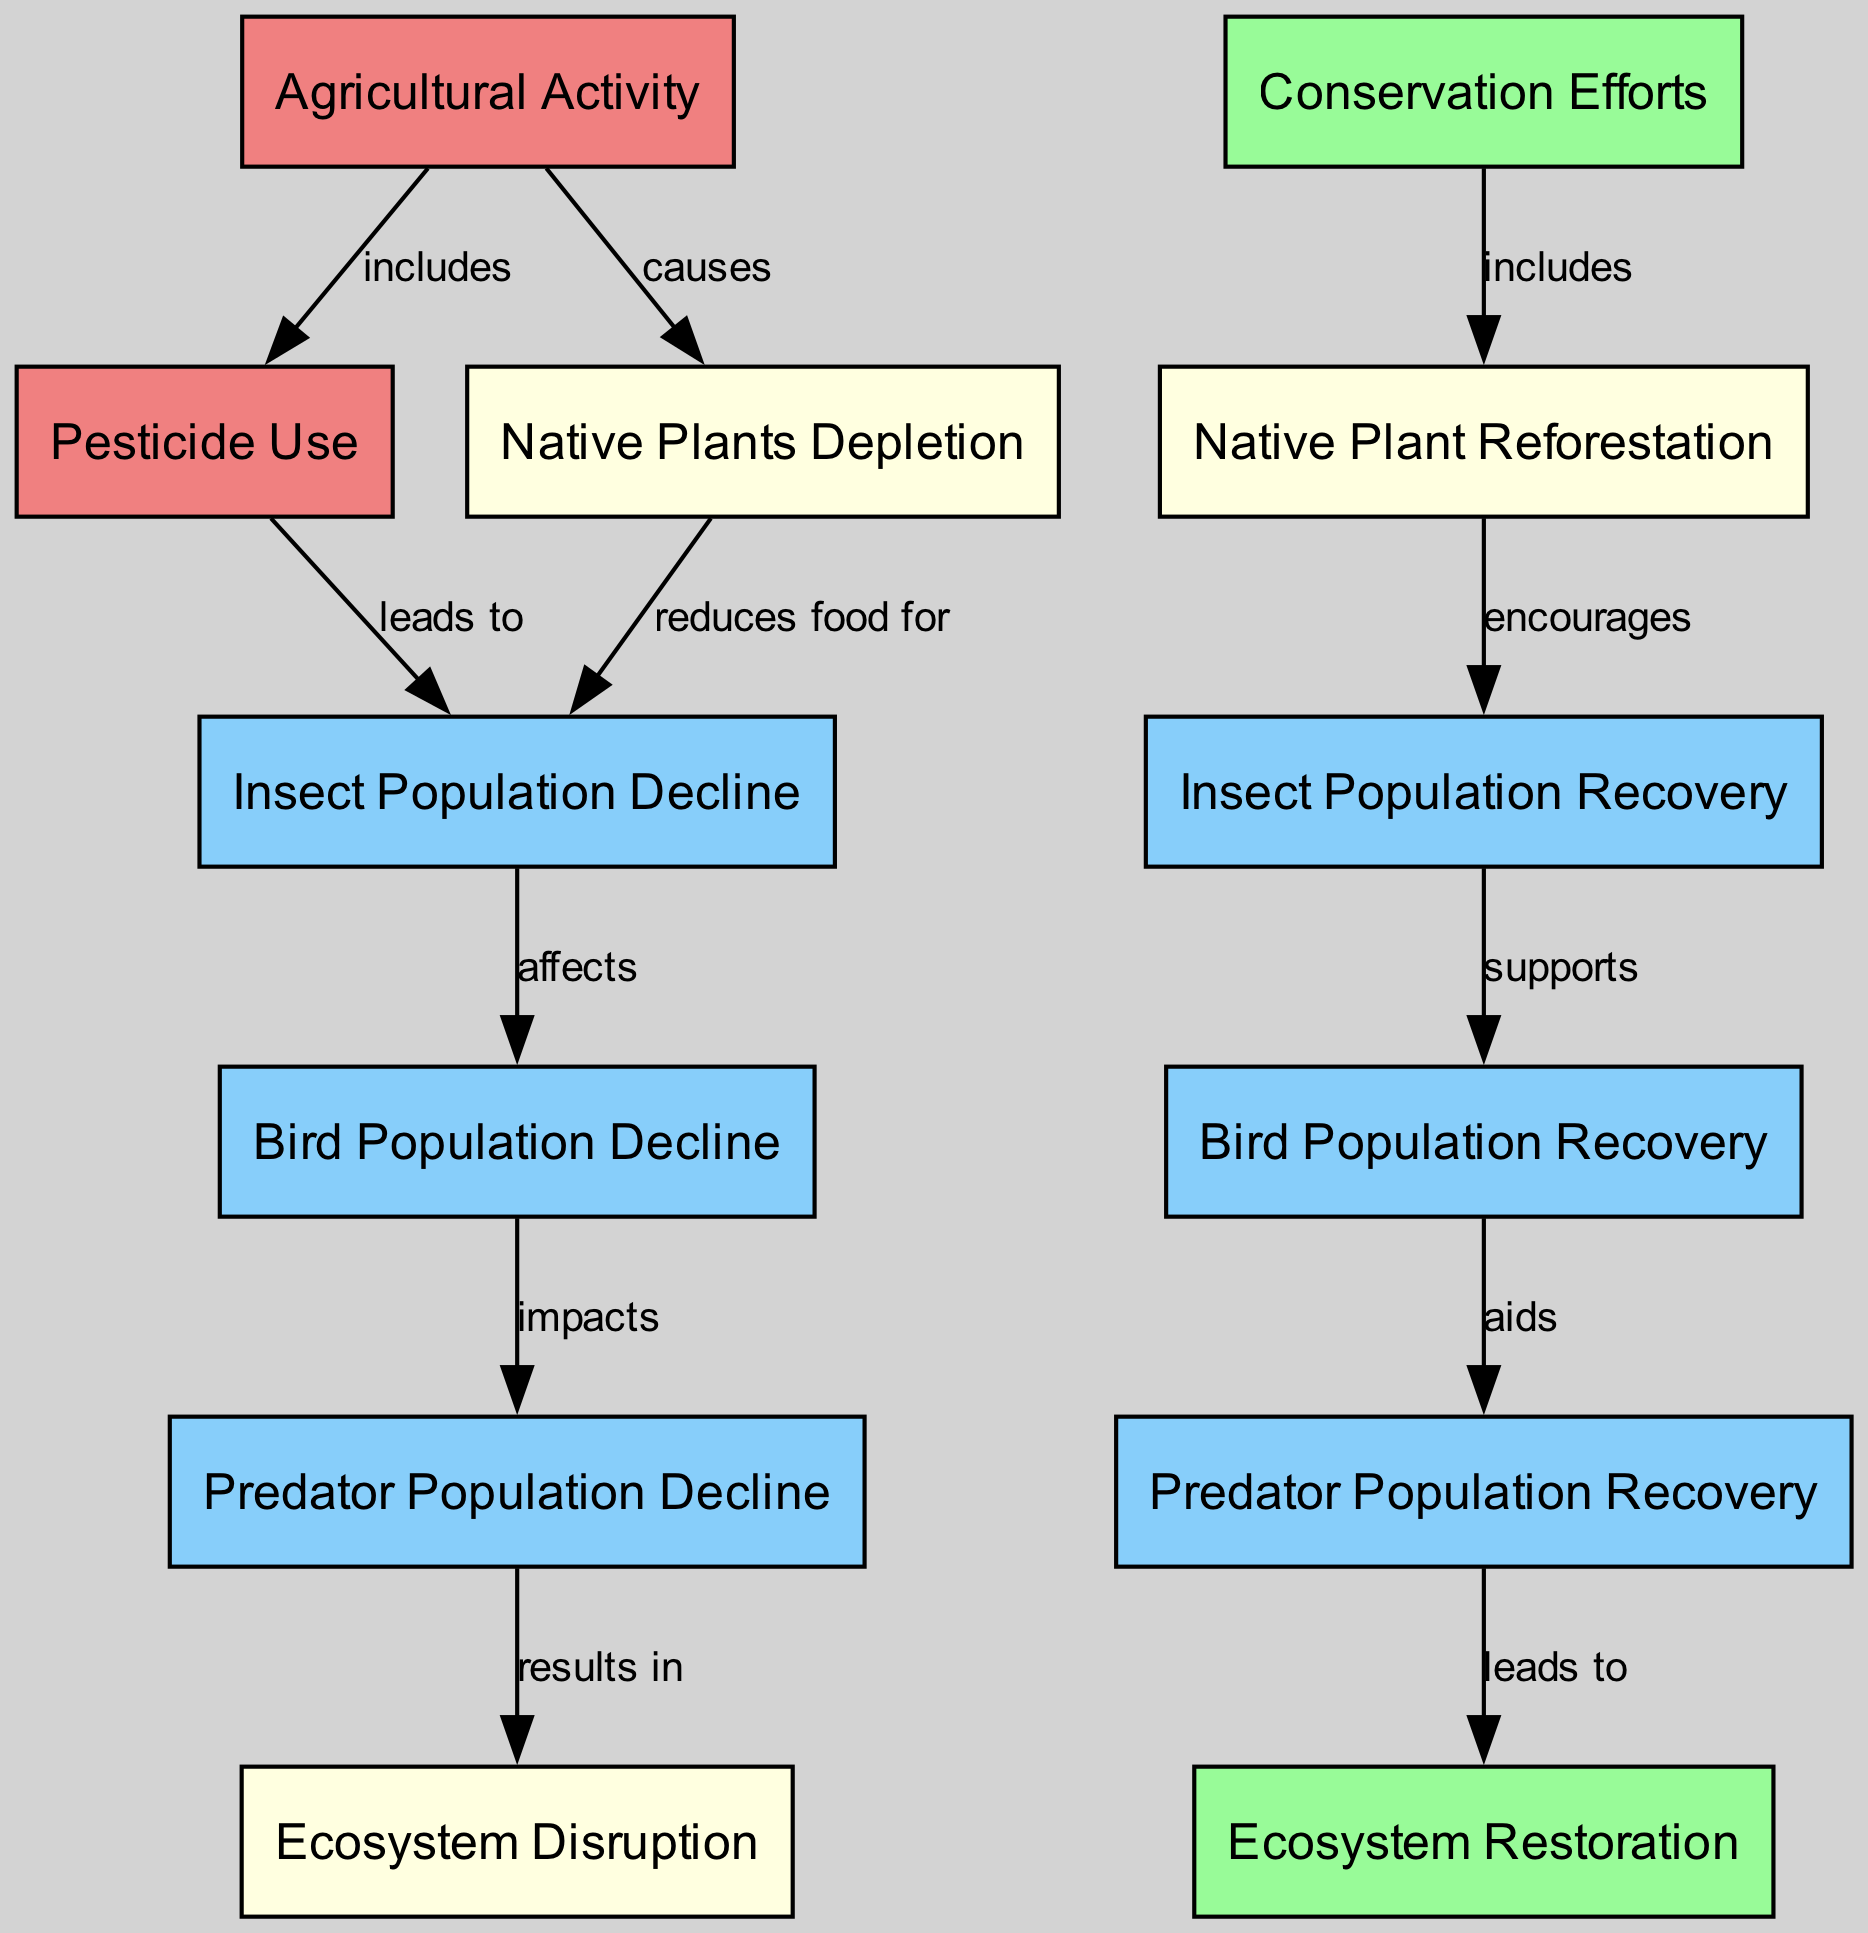What is the initial activity that causes various ecological issues? The initial activity depicted in the diagram is "Agricultural Activity." This is clearly shown at the starting point of the diagram, from which other issues branch out.
Answer: Agricultural Activity How many nodes represent population declines? The diagram includes three nodes specifically related to population declines: "Insect Population Decline," "Bird Population Decline," and "Predator Population Decline." Counting these nodes results in a total of three.
Answer: Three What directly leads to the "Ecosystem Disruption"? "Predator Population Decline" directly leads to "Ecosystem Disruption," as shown by the edge pointing from the former to the latter in the diagram.
Answer: Predator Population Decline Which conservation efforts are included in the diagram? The conservation effort included in the diagram is "Native Plant Reforestation." It is linked directly to conservation efforts, indicating it is part of that approach.
Answer: Native Plant Reforestation What is the relationship between "Insect Population Recovery" and "Bird Population Recovery"? "Insect Population Recovery" supports "Bird Population Recovery," which indicates that as insect populations recover, bird populations benefit, as shown by the directed edge between these nodes.
Answer: Supports If "Native Plants Depletion" occurs, what impact does it have on insect populations? "Native Plants Depletion" reduces food for "Insect Population Decline," which explicitly indicates that the decline in native plants will lead to a decrease in insect populations.
Answer: Reduces food for What results from conservation efforts according to the diagram? Conservation efforts lead to "Native Plant Reforestation," which is a direct connection made in the diagram, indicating that the efforts result in this specific action.
Answer: Native Plant Reforestation How do predator populations recover according to the diagram? "Predator Population Recovery" occurs as a result of bringing back bird populations, as indicated by the supporting connection from "Bird Population Recovery" to "Predator Population Recovery." This understanding illustrates the sequential influence of recovery in the food chain.
Answer: Aids What ultimately leads to "Ecosystem Restoration" in the food chain? The "Predator Population Recovery" leads to "Ecosystem Restoration," which is the final step indicated in the flow of the diagram, showing how the recovery of predators contributes to the restoration of the ecosystem.
Answer: Leads to 